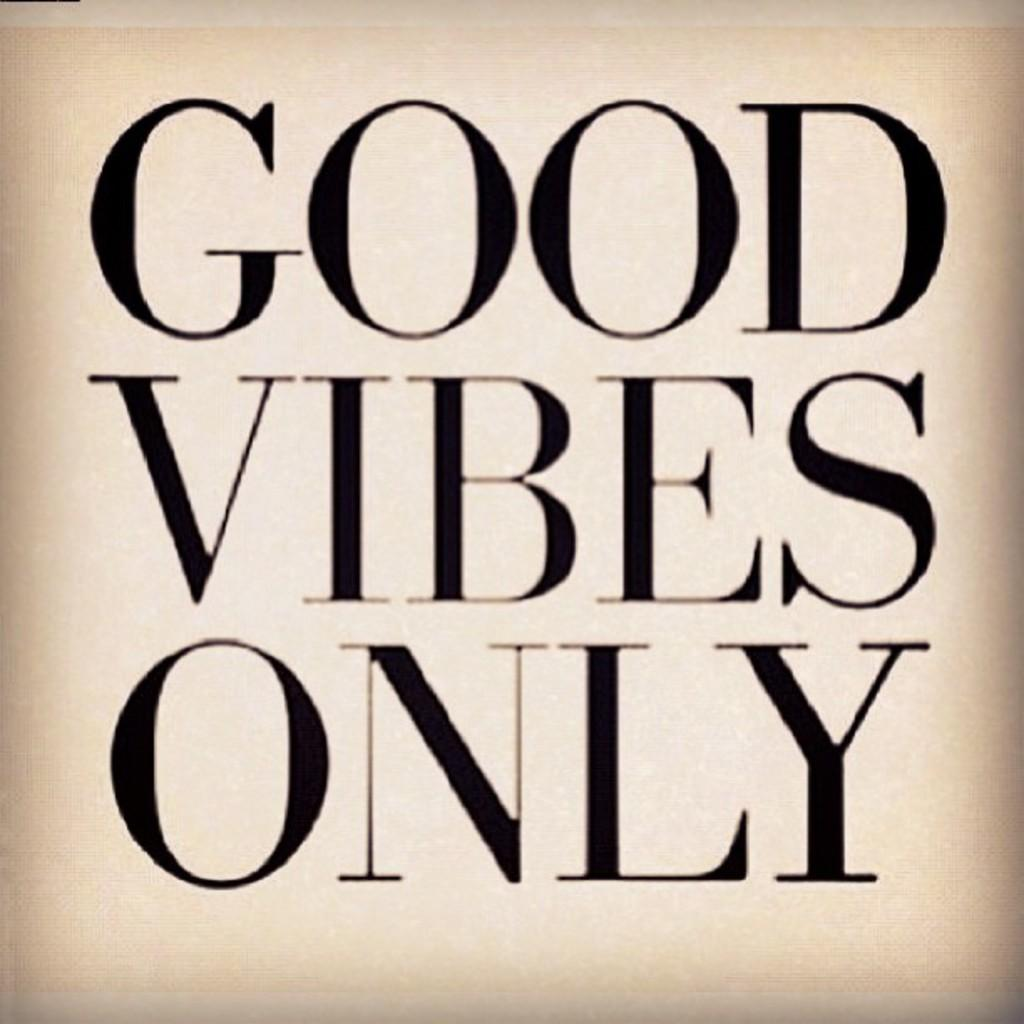What is the focus of the image? The image is zoomed in, so the focus is on a specific area or object. What can be seen in the center of the image? There is text on an object in the center of the image. What type of lawyer is depicted in the image? There is no lawyer present in the image; it only features text on an object. How many toes can be seen in the image? There are no toes visible in the image. 